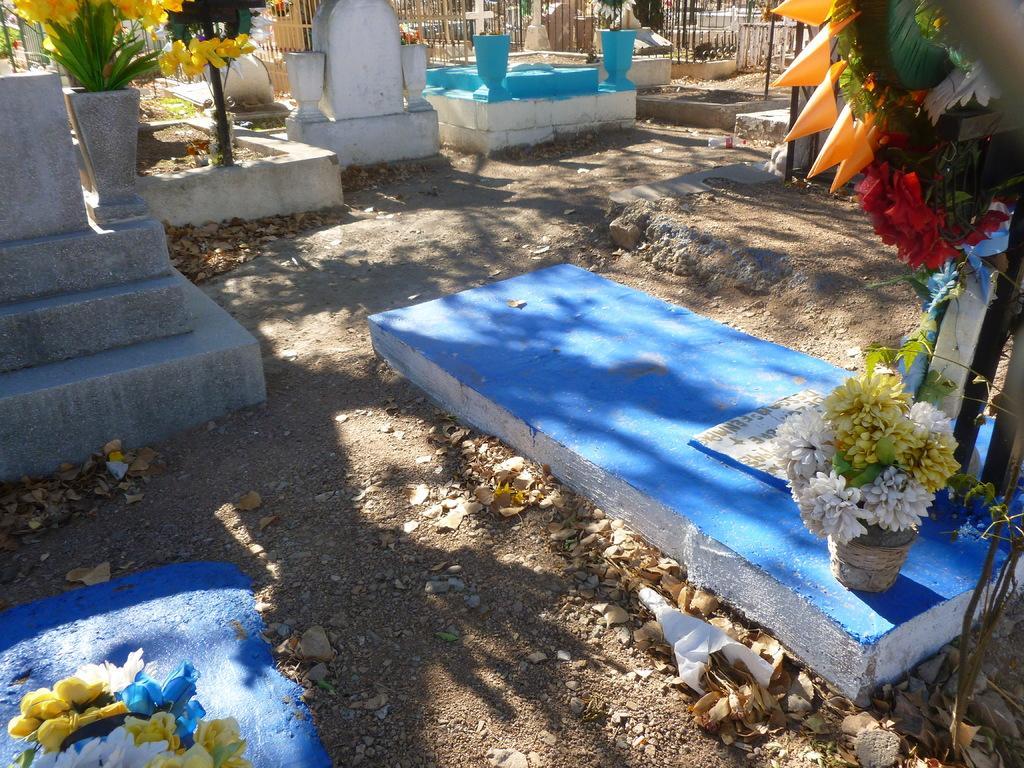In one or two sentences, can you explain what this image depicts? In this image we can see the view of a graveyard, there are graves, there are plants towards the top of the image, there are flowers towards the top of the image, there are flowers towards the bottom of the image, there is ground towards the bottom of the image, there are objects on the ground, there is a fence towards the top of the image, there are poles, there are objects towards the right of the image, there are stones on the ground. 